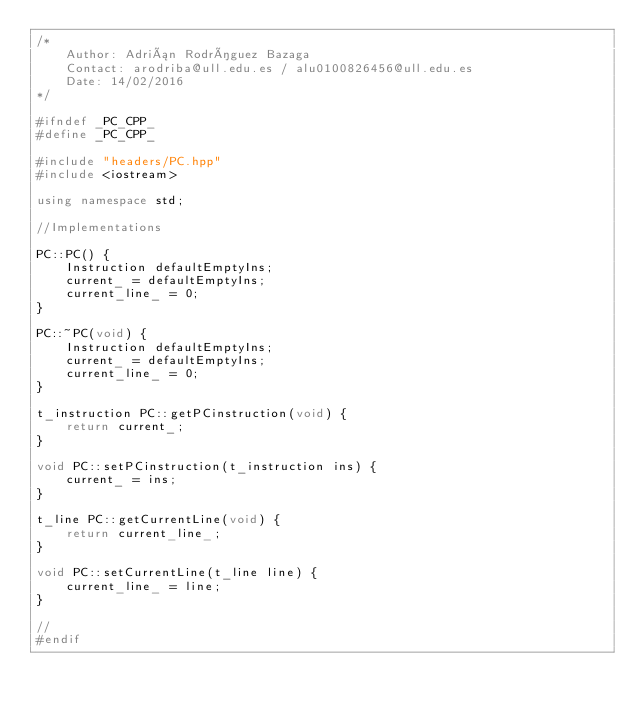Convert code to text. <code><loc_0><loc_0><loc_500><loc_500><_C++_>/*
    Author: Adrián Rodríguez Bazaga
    Contact: arodriba@ull.edu.es / alu0100826456@ull.edu.es
    Date: 14/02/2016
*/

#ifndef _PC_CPP_
#define _PC_CPP_

#include "headers/PC.hpp"
#include <iostream>

using namespace std;

//Implementations

PC::PC() {
    Instruction defaultEmptyIns;
    current_ = defaultEmptyIns;
    current_line_ = 0;
}

PC::~PC(void) { 
    Instruction defaultEmptyIns;
    current_ = defaultEmptyIns;
    current_line_ = 0;
}

t_instruction PC::getPCinstruction(void) {
    return current_;
}

void PC::setPCinstruction(t_instruction ins) {
    current_ = ins;
}

t_line PC::getCurrentLine(void) {
    return current_line_;
}

void PC::setCurrentLine(t_line line) {
    current_line_ = line;
}

//
#endif</code> 